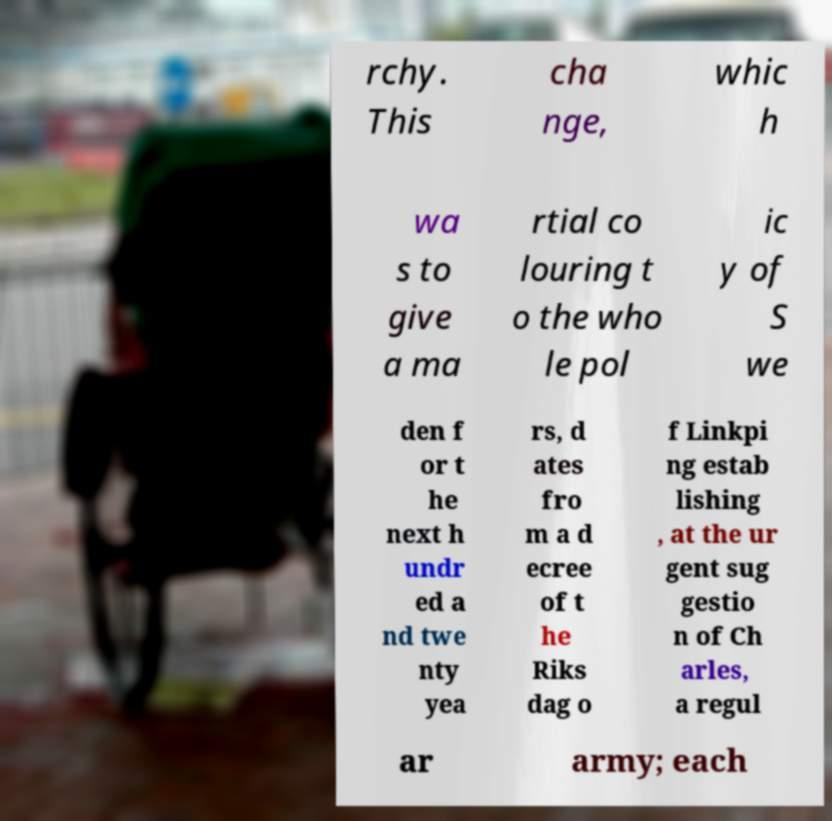What messages or text are displayed in this image? I need them in a readable, typed format. rchy. This cha nge, whic h wa s to give a ma rtial co louring t o the who le pol ic y of S we den f or t he next h undr ed a nd twe nty yea rs, d ates fro m a d ecree of t he Riks dag o f Linkpi ng estab lishing , at the ur gent sug gestio n of Ch arles, a regul ar army; each 